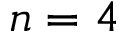Convert formula to latex. <formula><loc_0><loc_0><loc_500><loc_500>n = 4</formula> 